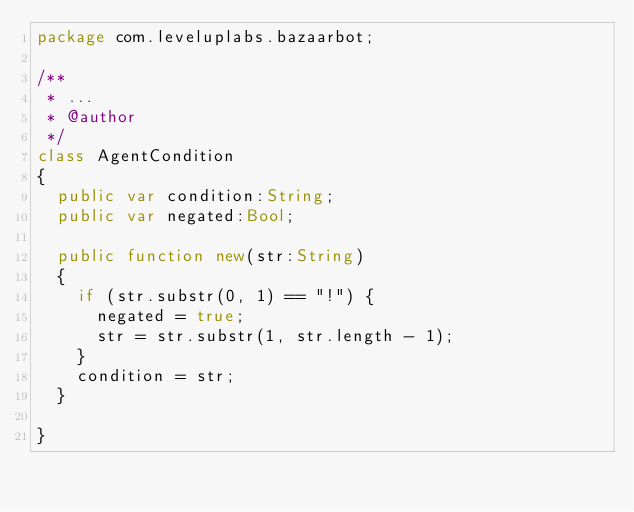<code> <loc_0><loc_0><loc_500><loc_500><_Haxe_>package com.leveluplabs.bazaarbot;

/**
 * ...
 * @author 
 */
class AgentCondition
{
	public var condition:String;
	public var negated:Bool;
	
	public function new(str:String) 
	{
		if (str.substr(0, 1) == "!") {
			negated = true;
			str = str.substr(1, str.length - 1);
		}
		condition = str;
	}
	
}</code> 